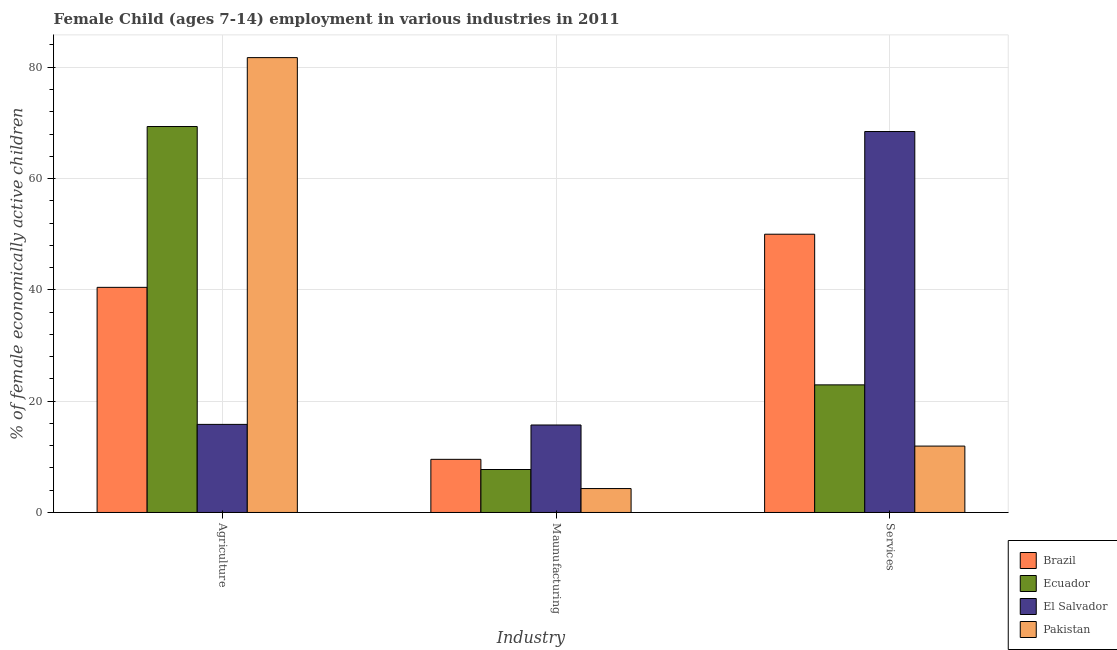How many different coloured bars are there?
Keep it short and to the point. 4. Are the number of bars on each tick of the X-axis equal?
Provide a short and direct response. Yes. What is the label of the 1st group of bars from the left?
Offer a very short reply. Agriculture. What is the percentage of economically active children in manufacturing in El Salvador?
Your answer should be compact. 15.72. Across all countries, what is the maximum percentage of economically active children in agriculture?
Your answer should be very brief. 81.73. In which country was the percentage of economically active children in agriculture minimum?
Your answer should be very brief. El Salvador. What is the total percentage of economically active children in manufacturing in the graph?
Offer a terse response. 37.29. What is the difference between the percentage of economically active children in agriculture in El Salvador and that in Ecuador?
Give a very brief answer. -53.52. What is the difference between the percentage of economically active children in agriculture in Pakistan and the percentage of economically active children in manufacturing in Ecuador?
Give a very brief answer. 74.01. What is the average percentage of economically active children in agriculture per country?
Ensure brevity in your answer.  51.84. What is the difference between the percentage of economically active children in manufacturing and percentage of economically active children in agriculture in Ecuador?
Make the answer very short. -61.63. In how many countries, is the percentage of economically active children in agriculture greater than 28 %?
Provide a succinct answer. 3. What is the ratio of the percentage of economically active children in agriculture in Ecuador to that in Brazil?
Provide a short and direct response. 1.71. What is the difference between the highest and the second highest percentage of economically active children in manufacturing?
Offer a terse response. 6.17. What is the difference between the highest and the lowest percentage of economically active children in manufacturing?
Your answer should be compact. 11.42. In how many countries, is the percentage of economically active children in manufacturing greater than the average percentage of economically active children in manufacturing taken over all countries?
Give a very brief answer. 2. What does the 3rd bar from the left in Maunufacturing represents?
Your answer should be very brief. El Salvador. What does the 2nd bar from the right in Maunufacturing represents?
Give a very brief answer. El Salvador. How many bars are there?
Your answer should be compact. 12. How many countries are there in the graph?
Give a very brief answer. 4. Are the values on the major ticks of Y-axis written in scientific E-notation?
Give a very brief answer. No. Does the graph contain any zero values?
Offer a very short reply. No. Does the graph contain grids?
Provide a short and direct response. Yes. Where does the legend appear in the graph?
Make the answer very short. Bottom right. What is the title of the graph?
Your answer should be compact. Female Child (ages 7-14) employment in various industries in 2011. Does "Uganda" appear as one of the legend labels in the graph?
Ensure brevity in your answer.  No. What is the label or title of the X-axis?
Your answer should be compact. Industry. What is the label or title of the Y-axis?
Make the answer very short. % of female economically active children. What is the % of female economically active children of Brazil in Agriculture?
Give a very brief answer. 40.45. What is the % of female economically active children of Ecuador in Agriculture?
Keep it short and to the point. 69.35. What is the % of female economically active children in El Salvador in Agriculture?
Your answer should be very brief. 15.83. What is the % of female economically active children in Pakistan in Agriculture?
Offer a very short reply. 81.73. What is the % of female economically active children of Brazil in Maunufacturing?
Provide a succinct answer. 9.55. What is the % of female economically active children in Ecuador in Maunufacturing?
Ensure brevity in your answer.  7.72. What is the % of female economically active children in El Salvador in Maunufacturing?
Your answer should be compact. 15.72. What is the % of female economically active children in Pakistan in Maunufacturing?
Ensure brevity in your answer.  4.3. What is the % of female economically active children of Ecuador in Services?
Your response must be concise. 22.93. What is the % of female economically active children of El Salvador in Services?
Your answer should be very brief. 68.45. What is the % of female economically active children of Pakistan in Services?
Provide a succinct answer. 11.93. Across all Industry, what is the maximum % of female economically active children in Brazil?
Offer a terse response. 50. Across all Industry, what is the maximum % of female economically active children of Ecuador?
Provide a short and direct response. 69.35. Across all Industry, what is the maximum % of female economically active children in El Salvador?
Offer a very short reply. 68.45. Across all Industry, what is the maximum % of female economically active children in Pakistan?
Your response must be concise. 81.73. Across all Industry, what is the minimum % of female economically active children in Brazil?
Provide a succinct answer. 9.55. Across all Industry, what is the minimum % of female economically active children in Ecuador?
Keep it short and to the point. 7.72. Across all Industry, what is the minimum % of female economically active children of El Salvador?
Your answer should be very brief. 15.72. What is the total % of female economically active children in Brazil in the graph?
Provide a succinct answer. 100. What is the total % of female economically active children in Ecuador in the graph?
Ensure brevity in your answer.  100. What is the total % of female economically active children of El Salvador in the graph?
Provide a short and direct response. 100. What is the total % of female economically active children in Pakistan in the graph?
Give a very brief answer. 97.96. What is the difference between the % of female economically active children of Brazil in Agriculture and that in Maunufacturing?
Ensure brevity in your answer.  30.9. What is the difference between the % of female economically active children in Ecuador in Agriculture and that in Maunufacturing?
Give a very brief answer. 61.63. What is the difference between the % of female economically active children of El Salvador in Agriculture and that in Maunufacturing?
Keep it short and to the point. 0.11. What is the difference between the % of female economically active children of Pakistan in Agriculture and that in Maunufacturing?
Make the answer very short. 77.43. What is the difference between the % of female economically active children in Brazil in Agriculture and that in Services?
Ensure brevity in your answer.  -9.55. What is the difference between the % of female economically active children in Ecuador in Agriculture and that in Services?
Provide a short and direct response. 46.42. What is the difference between the % of female economically active children in El Salvador in Agriculture and that in Services?
Give a very brief answer. -52.62. What is the difference between the % of female economically active children in Pakistan in Agriculture and that in Services?
Offer a very short reply. 69.8. What is the difference between the % of female economically active children in Brazil in Maunufacturing and that in Services?
Offer a terse response. -40.45. What is the difference between the % of female economically active children of Ecuador in Maunufacturing and that in Services?
Offer a very short reply. -15.21. What is the difference between the % of female economically active children of El Salvador in Maunufacturing and that in Services?
Provide a short and direct response. -52.73. What is the difference between the % of female economically active children of Pakistan in Maunufacturing and that in Services?
Your answer should be very brief. -7.63. What is the difference between the % of female economically active children in Brazil in Agriculture and the % of female economically active children in Ecuador in Maunufacturing?
Provide a short and direct response. 32.73. What is the difference between the % of female economically active children of Brazil in Agriculture and the % of female economically active children of El Salvador in Maunufacturing?
Keep it short and to the point. 24.73. What is the difference between the % of female economically active children in Brazil in Agriculture and the % of female economically active children in Pakistan in Maunufacturing?
Offer a terse response. 36.15. What is the difference between the % of female economically active children of Ecuador in Agriculture and the % of female economically active children of El Salvador in Maunufacturing?
Ensure brevity in your answer.  53.63. What is the difference between the % of female economically active children in Ecuador in Agriculture and the % of female economically active children in Pakistan in Maunufacturing?
Give a very brief answer. 65.05. What is the difference between the % of female economically active children of El Salvador in Agriculture and the % of female economically active children of Pakistan in Maunufacturing?
Ensure brevity in your answer.  11.53. What is the difference between the % of female economically active children of Brazil in Agriculture and the % of female economically active children of Ecuador in Services?
Give a very brief answer. 17.52. What is the difference between the % of female economically active children of Brazil in Agriculture and the % of female economically active children of Pakistan in Services?
Give a very brief answer. 28.52. What is the difference between the % of female economically active children of Ecuador in Agriculture and the % of female economically active children of El Salvador in Services?
Your response must be concise. 0.9. What is the difference between the % of female economically active children in Ecuador in Agriculture and the % of female economically active children in Pakistan in Services?
Provide a succinct answer. 57.42. What is the difference between the % of female economically active children of El Salvador in Agriculture and the % of female economically active children of Pakistan in Services?
Your answer should be compact. 3.9. What is the difference between the % of female economically active children in Brazil in Maunufacturing and the % of female economically active children in Ecuador in Services?
Your response must be concise. -13.38. What is the difference between the % of female economically active children in Brazil in Maunufacturing and the % of female economically active children in El Salvador in Services?
Your answer should be compact. -58.9. What is the difference between the % of female economically active children in Brazil in Maunufacturing and the % of female economically active children in Pakistan in Services?
Your response must be concise. -2.38. What is the difference between the % of female economically active children of Ecuador in Maunufacturing and the % of female economically active children of El Salvador in Services?
Your answer should be compact. -60.73. What is the difference between the % of female economically active children of Ecuador in Maunufacturing and the % of female economically active children of Pakistan in Services?
Offer a very short reply. -4.21. What is the difference between the % of female economically active children of El Salvador in Maunufacturing and the % of female economically active children of Pakistan in Services?
Your response must be concise. 3.79. What is the average % of female economically active children of Brazil per Industry?
Offer a very short reply. 33.33. What is the average % of female economically active children of Ecuador per Industry?
Your answer should be compact. 33.33. What is the average % of female economically active children of El Salvador per Industry?
Provide a short and direct response. 33.33. What is the average % of female economically active children in Pakistan per Industry?
Offer a very short reply. 32.65. What is the difference between the % of female economically active children of Brazil and % of female economically active children of Ecuador in Agriculture?
Your answer should be very brief. -28.9. What is the difference between the % of female economically active children in Brazil and % of female economically active children in El Salvador in Agriculture?
Your answer should be very brief. 24.62. What is the difference between the % of female economically active children of Brazil and % of female economically active children of Pakistan in Agriculture?
Provide a succinct answer. -41.28. What is the difference between the % of female economically active children in Ecuador and % of female economically active children in El Salvador in Agriculture?
Offer a very short reply. 53.52. What is the difference between the % of female economically active children of Ecuador and % of female economically active children of Pakistan in Agriculture?
Offer a very short reply. -12.38. What is the difference between the % of female economically active children in El Salvador and % of female economically active children in Pakistan in Agriculture?
Your answer should be compact. -65.9. What is the difference between the % of female economically active children of Brazil and % of female economically active children of Ecuador in Maunufacturing?
Offer a very short reply. 1.83. What is the difference between the % of female economically active children of Brazil and % of female economically active children of El Salvador in Maunufacturing?
Offer a terse response. -6.17. What is the difference between the % of female economically active children in Brazil and % of female economically active children in Pakistan in Maunufacturing?
Give a very brief answer. 5.25. What is the difference between the % of female economically active children in Ecuador and % of female economically active children in Pakistan in Maunufacturing?
Ensure brevity in your answer.  3.42. What is the difference between the % of female economically active children in El Salvador and % of female economically active children in Pakistan in Maunufacturing?
Keep it short and to the point. 11.42. What is the difference between the % of female economically active children of Brazil and % of female economically active children of Ecuador in Services?
Provide a short and direct response. 27.07. What is the difference between the % of female economically active children in Brazil and % of female economically active children in El Salvador in Services?
Keep it short and to the point. -18.45. What is the difference between the % of female economically active children in Brazil and % of female economically active children in Pakistan in Services?
Offer a terse response. 38.07. What is the difference between the % of female economically active children of Ecuador and % of female economically active children of El Salvador in Services?
Offer a very short reply. -45.52. What is the difference between the % of female economically active children in Ecuador and % of female economically active children in Pakistan in Services?
Keep it short and to the point. 11. What is the difference between the % of female economically active children of El Salvador and % of female economically active children of Pakistan in Services?
Make the answer very short. 56.52. What is the ratio of the % of female economically active children of Brazil in Agriculture to that in Maunufacturing?
Offer a terse response. 4.24. What is the ratio of the % of female economically active children in Ecuador in Agriculture to that in Maunufacturing?
Make the answer very short. 8.98. What is the ratio of the % of female economically active children in Pakistan in Agriculture to that in Maunufacturing?
Give a very brief answer. 19.01. What is the ratio of the % of female economically active children of Brazil in Agriculture to that in Services?
Make the answer very short. 0.81. What is the ratio of the % of female economically active children of Ecuador in Agriculture to that in Services?
Make the answer very short. 3.02. What is the ratio of the % of female economically active children in El Salvador in Agriculture to that in Services?
Your answer should be compact. 0.23. What is the ratio of the % of female economically active children of Pakistan in Agriculture to that in Services?
Offer a terse response. 6.85. What is the ratio of the % of female economically active children of Brazil in Maunufacturing to that in Services?
Your answer should be compact. 0.19. What is the ratio of the % of female economically active children in Ecuador in Maunufacturing to that in Services?
Keep it short and to the point. 0.34. What is the ratio of the % of female economically active children in El Salvador in Maunufacturing to that in Services?
Provide a short and direct response. 0.23. What is the ratio of the % of female economically active children of Pakistan in Maunufacturing to that in Services?
Keep it short and to the point. 0.36. What is the difference between the highest and the second highest % of female economically active children in Brazil?
Your answer should be very brief. 9.55. What is the difference between the highest and the second highest % of female economically active children in Ecuador?
Make the answer very short. 46.42. What is the difference between the highest and the second highest % of female economically active children of El Salvador?
Provide a short and direct response. 52.62. What is the difference between the highest and the second highest % of female economically active children in Pakistan?
Give a very brief answer. 69.8. What is the difference between the highest and the lowest % of female economically active children in Brazil?
Keep it short and to the point. 40.45. What is the difference between the highest and the lowest % of female economically active children in Ecuador?
Offer a very short reply. 61.63. What is the difference between the highest and the lowest % of female economically active children of El Salvador?
Keep it short and to the point. 52.73. What is the difference between the highest and the lowest % of female economically active children in Pakistan?
Provide a succinct answer. 77.43. 